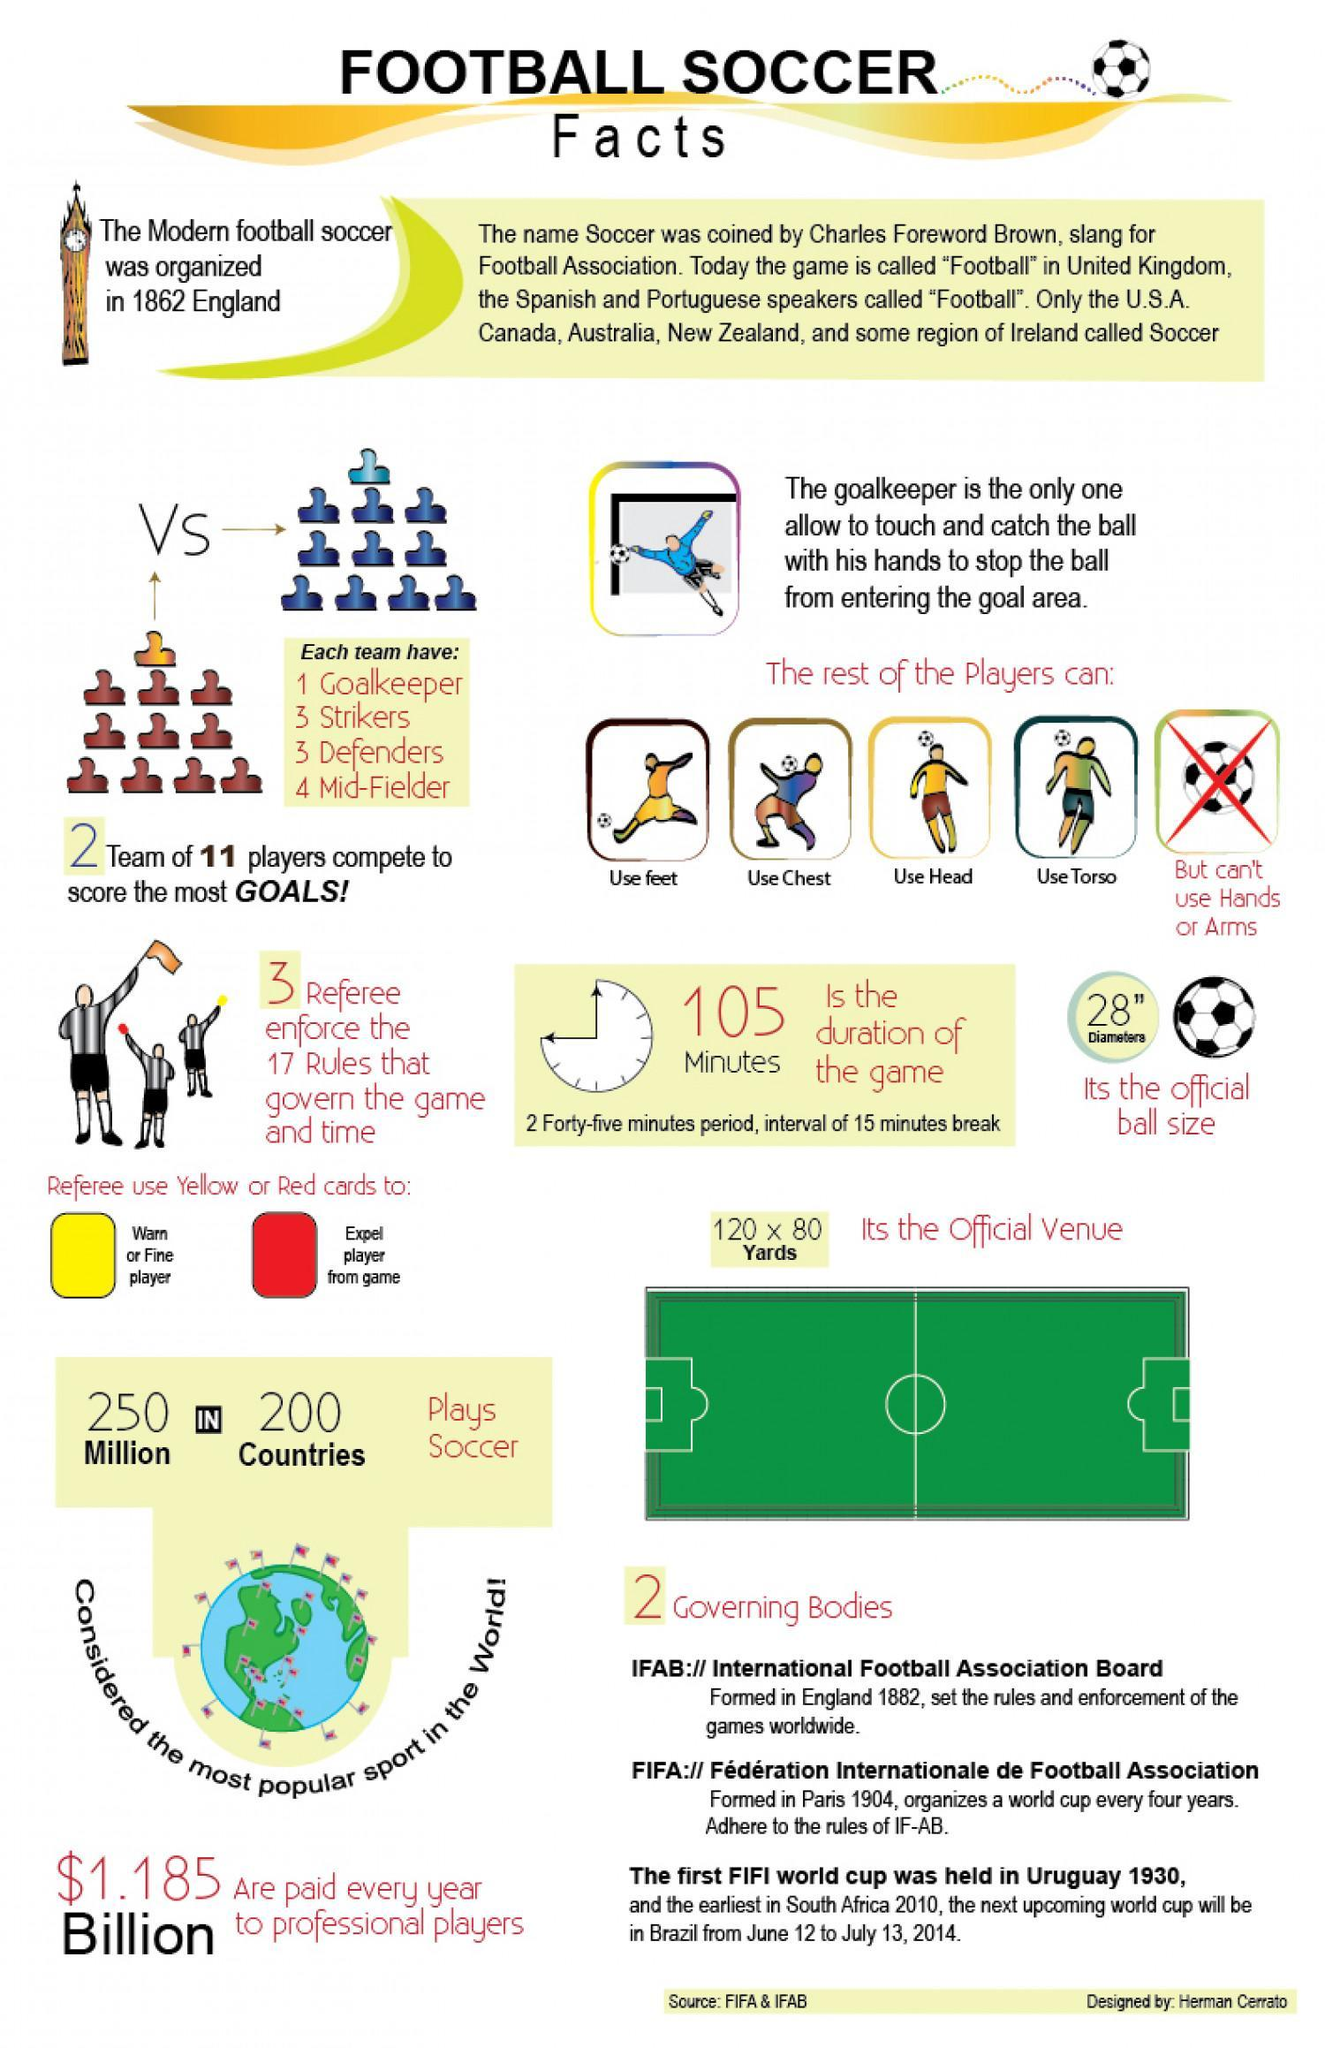Which color card is used to warn a player-green, red, orange, or yellow?
Answer the question with a short phrase. yellow Which color card is used to expel a player from game-yellow, green, red, or orange? red How many footballs are in this infographic? 8 